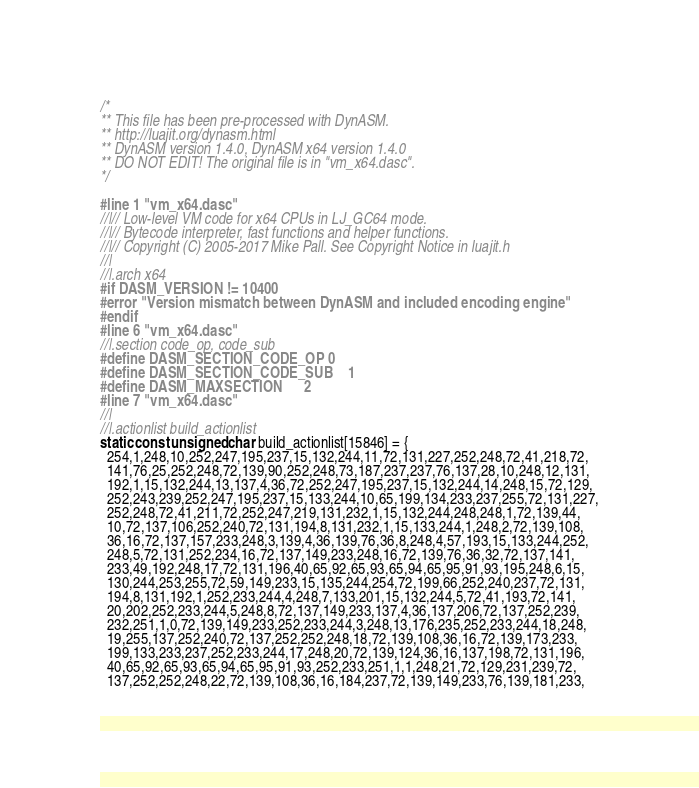Convert code to text. <code><loc_0><loc_0><loc_500><loc_500><_C_>/*
** This file has been pre-processed with DynASM.
** http://luajit.org/dynasm.html
** DynASM version 1.4.0, DynASM x64 version 1.4.0
** DO NOT EDIT! The original file is in "vm_x64.dasc".
*/

#line 1 "vm_x64.dasc"
//|// Low-level VM code for x64 CPUs in LJ_GC64 mode.
//|// Bytecode interpreter, fast functions and helper functions.
//|// Copyright (C) 2005-2017 Mike Pall. See Copyright Notice in luajit.h
//|
//|.arch x64
#if DASM_VERSION != 10400
#error "Version mismatch between DynASM and included encoding engine"
#endif
#line 6 "vm_x64.dasc"
//|.section code_op, code_sub
#define DASM_SECTION_CODE_OP	0
#define DASM_SECTION_CODE_SUB	1
#define DASM_MAXSECTION		2
#line 7 "vm_x64.dasc"
//|
//|.actionlist build_actionlist
static const unsigned char build_actionlist[15846] = {
  254,1,248,10,252,247,195,237,15,132,244,11,72,131,227,252,248,72,41,218,72,
  141,76,25,252,248,72,139,90,252,248,73,187,237,237,76,137,28,10,248,12,131,
  192,1,15,132,244,13,137,4,36,72,252,247,195,237,15,132,244,14,248,15,72,129,
  252,243,239,252,247,195,237,15,133,244,10,65,199,134,233,237,255,72,131,227,
  252,248,72,41,211,72,252,247,219,131,232,1,15,132,244,248,248,1,72,139,44,
  10,72,137,106,252,240,72,131,194,8,131,232,1,15,133,244,1,248,2,72,139,108,
  36,16,72,137,157,233,248,3,139,4,36,139,76,36,8,248,4,57,193,15,133,244,252,
  248,5,72,131,252,234,16,72,137,149,233,248,16,72,139,76,36,32,72,137,141,
  233,49,192,248,17,72,131,196,40,65,92,65,93,65,94,65,95,91,93,195,248,6,15,
  130,244,253,255,72,59,149,233,15,135,244,254,72,199,66,252,240,237,72,131,
  194,8,131,192,1,252,233,244,4,248,7,133,201,15,132,244,5,72,41,193,72,141,
  20,202,252,233,244,5,248,8,72,137,149,233,137,4,36,137,206,72,137,252,239,
  232,251,1,0,72,139,149,233,252,233,244,3,248,13,176,235,252,233,244,18,248,
  19,255,137,252,240,72,137,252,252,248,18,72,139,108,36,16,72,139,173,233,
  199,133,233,237,252,233,244,17,248,20,72,139,124,36,16,137,198,72,131,196,
  40,65,92,65,93,65,94,65,95,91,93,252,233,251,1,1,248,21,72,129,231,239,72,
  137,252,252,248,22,72,139,108,36,16,184,237,72,139,149,233,76,139,181,233,</code> 